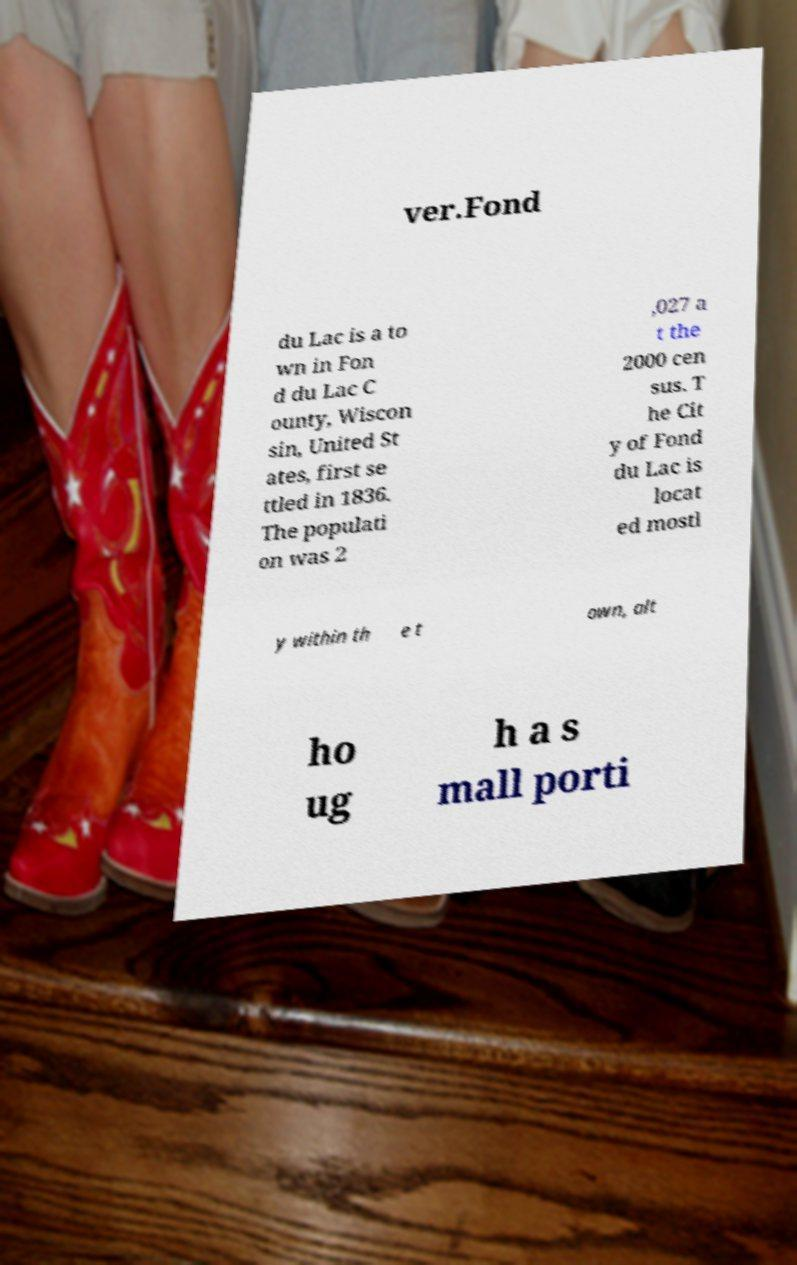Could you extract and type out the text from this image? ver.Fond du Lac is a to wn in Fon d du Lac C ounty, Wiscon sin, United St ates, first se ttled in 1836. The populati on was 2 ,027 a t the 2000 cen sus. T he Cit y of Fond du Lac is locat ed mostl y within th e t own, alt ho ug h a s mall porti 